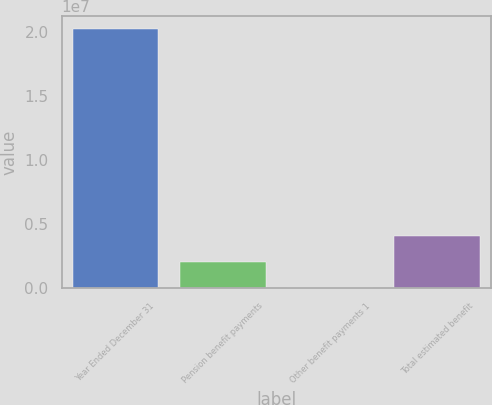Convert chart. <chart><loc_0><loc_0><loc_500><loc_500><bar_chart><fcel>Year Ended December 31<fcel>Pension benefit payments<fcel>Other benefit payments 1<fcel>Total estimated benefit<nl><fcel>2.0192e+07<fcel>2.01951e+06<fcel>346<fcel>4.03868e+06<nl></chart> 